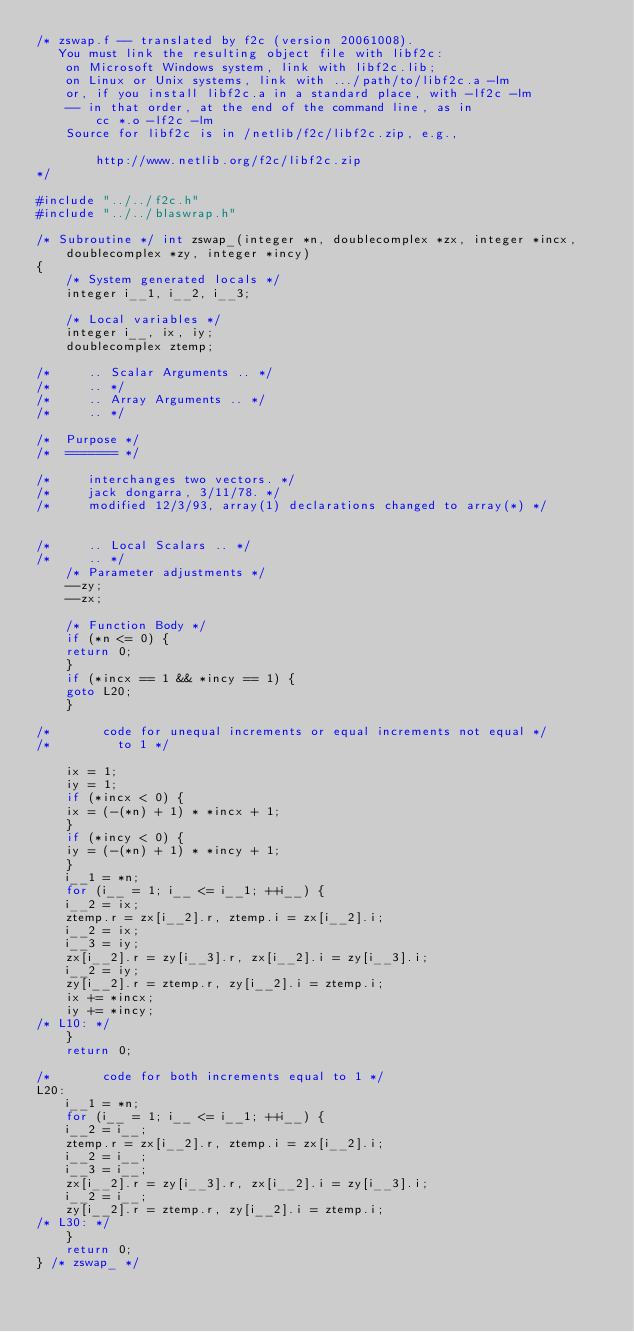Convert code to text. <code><loc_0><loc_0><loc_500><loc_500><_C_>/* zswap.f -- translated by f2c (version 20061008).
   You must link the resulting object file with libf2c:
	on Microsoft Windows system, link with libf2c.lib;
	on Linux or Unix systems, link with .../path/to/libf2c.a -lm
	or, if you install libf2c.a in a standard place, with -lf2c -lm
	-- in that order, at the end of the command line, as in
		cc *.o -lf2c -lm
	Source for libf2c is in /netlib/f2c/libf2c.zip, e.g.,

		http://www.netlib.org/f2c/libf2c.zip
*/

#include "../../f2c.h"
#include "../../blaswrap.h"

/* Subroutine */ int zswap_(integer *n, doublecomplex *zx, integer *incx, 
	doublecomplex *zy, integer *incy)
{
    /* System generated locals */
    integer i__1, i__2, i__3;

    /* Local variables */
    integer i__, ix, iy;
    doublecomplex ztemp;

/*     .. Scalar Arguments .. */
/*     .. */
/*     .. Array Arguments .. */
/*     .. */

/*  Purpose */
/*  ======= */

/*     interchanges two vectors. */
/*     jack dongarra, 3/11/78. */
/*     modified 12/3/93, array(1) declarations changed to array(*) */


/*     .. Local Scalars .. */
/*     .. */
    /* Parameter adjustments */
    --zy;
    --zx;

    /* Function Body */
    if (*n <= 0) {
	return 0;
    }
    if (*incx == 1 && *incy == 1) {
	goto L20;
    }

/*       code for unequal increments or equal increments not equal */
/*         to 1 */

    ix = 1;
    iy = 1;
    if (*incx < 0) {
	ix = (-(*n) + 1) * *incx + 1;
    }
    if (*incy < 0) {
	iy = (-(*n) + 1) * *incy + 1;
    }
    i__1 = *n;
    for (i__ = 1; i__ <= i__1; ++i__) {
	i__2 = ix;
	ztemp.r = zx[i__2].r, ztemp.i = zx[i__2].i;
	i__2 = ix;
	i__3 = iy;
	zx[i__2].r = zy[i__3].r, zx[i__2].i = zy[i__3].i;
	i__2 = iy;
	zy[i__2].r = ztemp.r, zy[i__2].i = ztemp.i;
	ix += *incx;
	iy += *incy;
/* L10: */
    }
    return 0;

/*       code for both increments equal to 1 */
L20:
    i__1 = *n;
    for (i__ = 1; i__ <= i__1; ++i__) {
	i__2 = i__;
	ztemp.r = zx[i__2].r, ztemp.i = zx[i__2].i;
	i__2 = i__;
	i__3 = i__;
	zx[i__2].r = zy[i__3].r, zx[i__2].i = zy[i__3].i;
	i__2 = i__;
	zy[i__2].r = ztemp.r, zy[i__2].i = ztemp.i;
/* L30: */
    }
    return 0;
} /* zswap_ */
</code> 